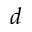<formula> <loc_0><loc_0><loc_500><loc_500>d</formula> 